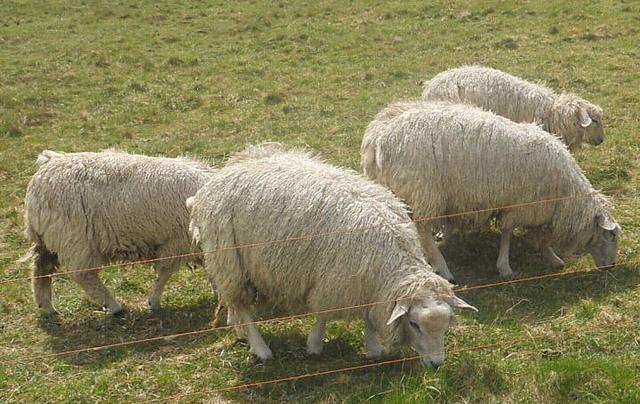How many sheep?
Write a very short answer. 4. What is holding the sheep in there area?
Be succinct. Fence. Are the sheep eating?
Write a very short answer. Yes. 